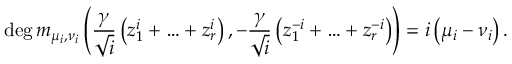<formula> <loc_0><loc_0><loc_500><loc_500>\deg m _ { \mu _ { i } , \nu _ { i } } \left ( \frac { \gamma } { \sqrt { i } } \left ( z _ { 1 } ^ { i } + \dots + z _ { r } ^ { i } \right ) , - \frac { \gamma } { \sqrt { i } } \left ( z _ { 1 } ^ { - i } + \dots + z _ { r } ^ { - i } \right ) \right ) = i \left ( \mu _ { i } - \nu _ { i } \right ) .</formula> 